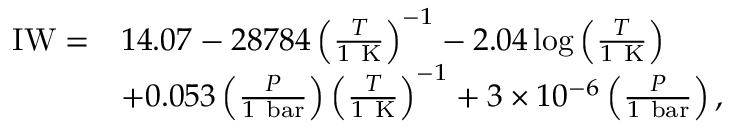<formula> <loc_0><loc_0><loc_500><loc_500>\begin{array} { r l } { I W = } & { 1 4 . 0 7 - 2 8 7 8 4 \left ( \frac { T } { 1 K } \right ) ^ { - 1 } - 2 . 0 4 \log { \left ( \frac { T } { 1 K } \right ) } } \\ & { + 0 . 0 5 3 \left ( \frac { P } { 1 b a r } \right ) \left ( \frac { T } { 1 K } \right ) ^ { - 1 } + 3 \times 1 0 ^ { - 6 } \left ( \frac { P } { 1 b a r } \right ) , } \end{array}</formula> 